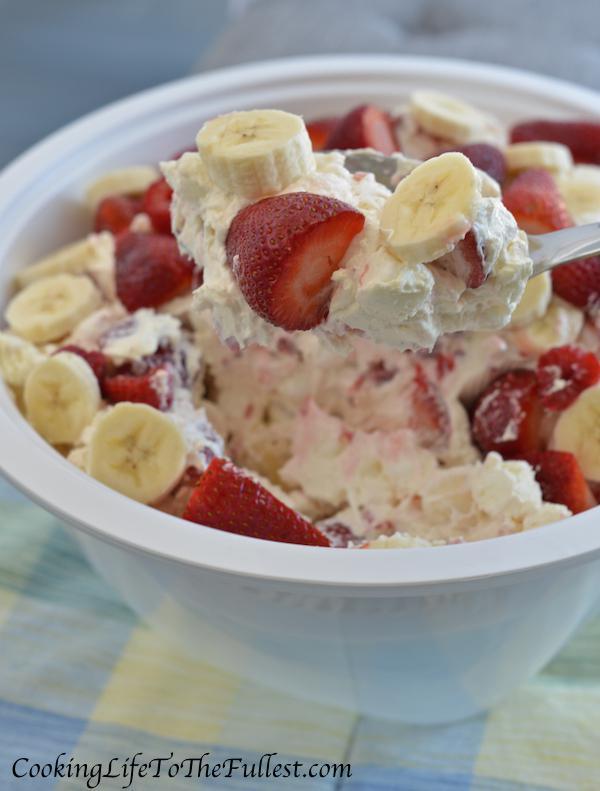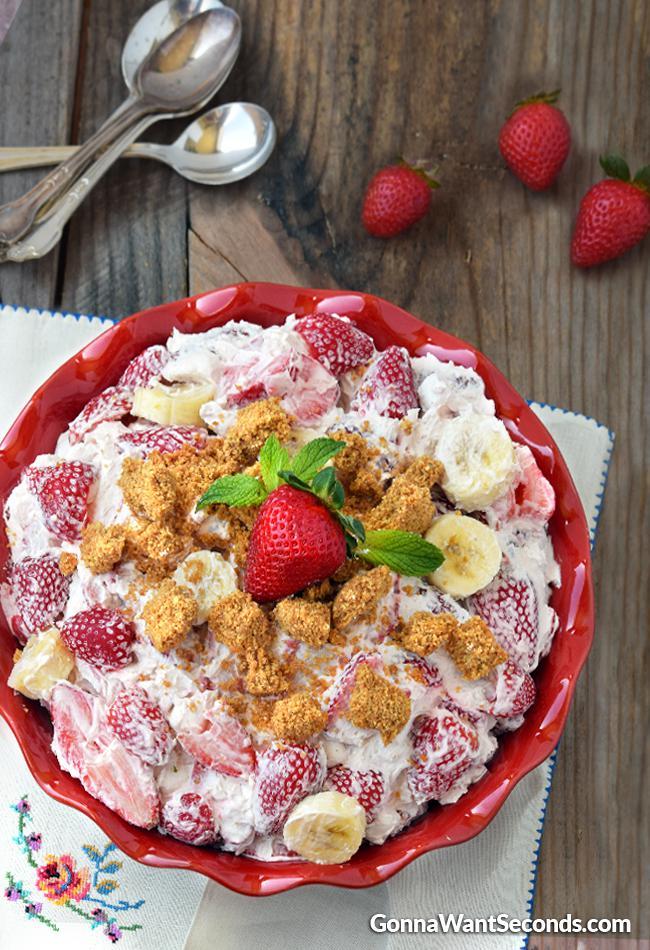The first image is the image on the left, the second image is the image on the right. Examine the images to the left and right. Is the description "An image shows a bowl topped with strawberry and a green leafy spring." accurate? Answer yes or no. Yes. The first image is the image on the left, the second image is the image on the right. Considering the images on both sides, is "There is an eating utensil next to a bowl of fruit salad." valid? Answer yes or no. Yes. 